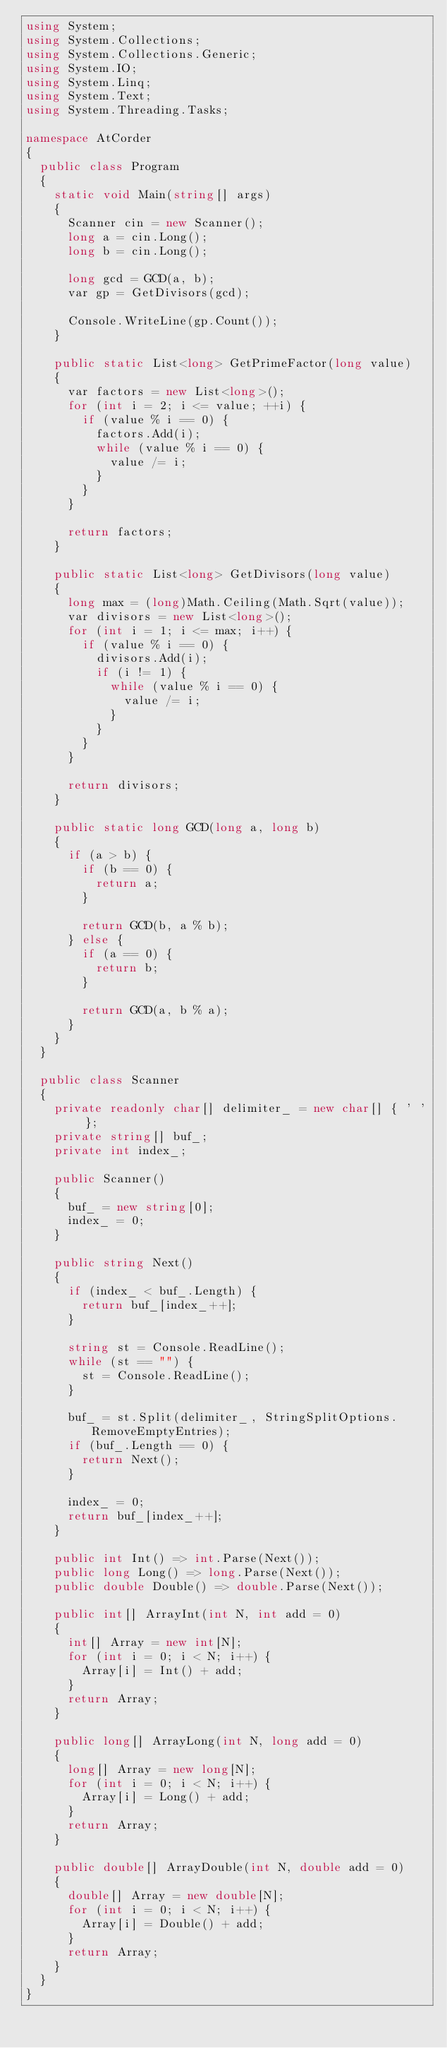<code> <loc_0><loc_0><loc_500><loc_500><_C#_>using System;
using System.Collections;
using System.Collections.Generic;
using System.IO;
using System.Linq;
using System.Text;
using System.Threading.Tasks;

namespace AtCorder
{
	public class Program
	{
		static void Main(string[] args)
		{
			Scanner cin = new Scanner();
			long a = cin.Long();
			long b = cin.Long();

			long gcd = GCD(a, b);
			var gp = GetDivisors(gcd);

			Console.WriteLine(gp.Count());
		}

		public static List<long> GetPrimeFactor(long value)
		{
			var factors = new List<long>();
			for (int i = 2; i <= value; ++i) {
				if (value % i == 0) {
					factors.Add(i);
					while (value % i == 0) {
						value /= i;
					}
				}
			}

			return factors;
		}

		public static List<long> GetDivisors(long value)
		{
			long max = (long)Math.Ceiling(Math.Sqrt(value));
			var divisors = new List<long>();
			for (int i = 1; i <= max; i++) {
				if (value % i == 0) {
					divisors.Add(i);
					if (i != 1) {
						while (value % i == 0) {
							value /= i;
						}
					}
				}
			}

			return divisors;
		}

		public static long GCD(long a, long b)
		{
			if (a > b) {
				if (b == 0) {
					return a;
				}

				return GCD(b, a % b);
			} else {
				if (a == 0) {
					return b;
				}

				return GCD(a, b % a);
			}
		}
	}

	public class Scanner
	{
		private readonly char[] delimiter_ = new char[] { ' ' };
		private string[] buf_;
		private int index_;

		public Scanner()
		{
			buf_ = new string[0];
			index_ = 0;
		}

		public string Next()
		{
			if (index_ < buf_.Length) {
				return buf_[index_++];
			}

			string st = Console.ReadLine();
			while (st == "") {
				st = Console.ReadLine();
			}

			buf_ = st.Split(delimiter_, StringSplitOptions.RemoveEmptyEntries);
			if (buf_.Length == 0) {
				return Next();
			}

			index_ = 0;
			return buf_[index_++];
		}

		public int Int() => int.Parse(Next());
		public long Long() => long.Parse(Next());
		public double Double() => double.Parse(Next());

		public int[] ArrayInt(int N, int add = 0)
		{
			int[] Array = new int[N];
			for (int i = 0; i < N; i++) {
				Array[i] = Int() + add;
			}
			return Array;
		}

		public long[] ArrayLong(int N, long add = 0)
		{
			long[] Array = new long[N];
			for (int i = 0; i < N; i++) {
				Array[i] = Long() + add;
			}
			return Array;
		}

		public double[] ArrayDouble(int N, double add = 0)
		{
			double[] Array = new double[N];
			for (int i = 0; i < N; i++) {
				Array[i] = Double() + add;
			}
			return Array;
		}
	}
}</code> 